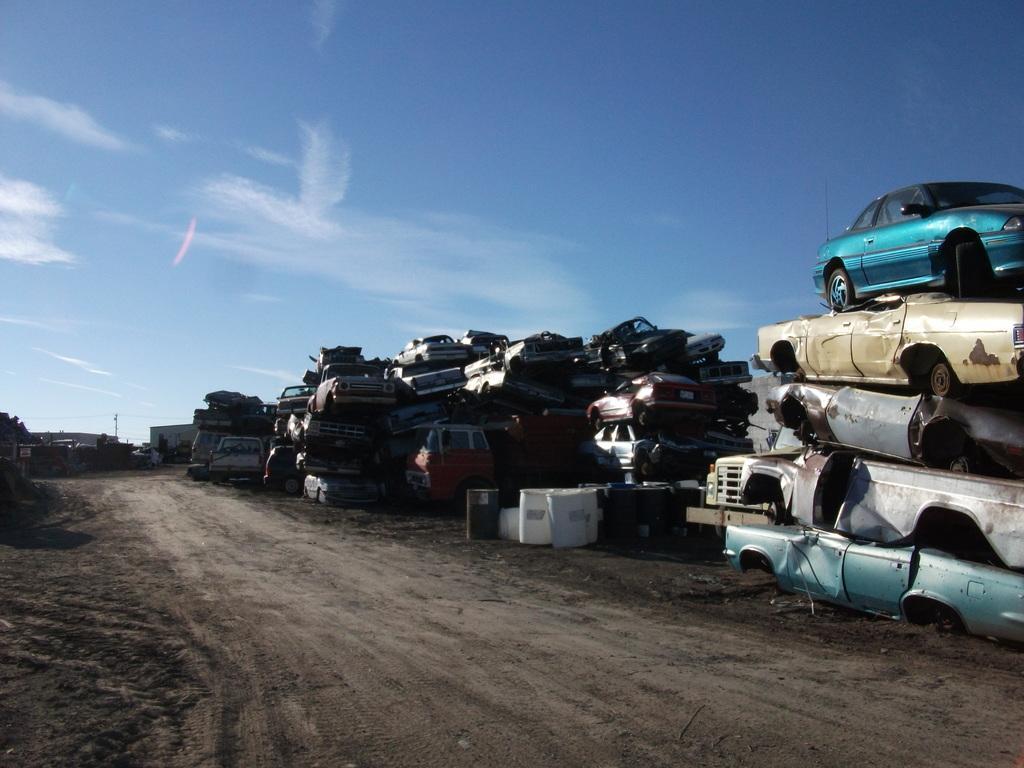In one or two sentences, can you explain what this image depicts? In this image I can see a road , on the road I can see group of cars, some containers visible at the top there is the sky visible. 